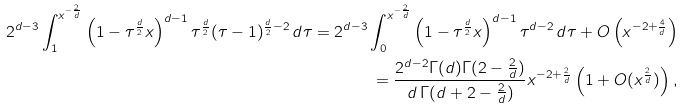Convert formula to latex. <formula><loc_0><loc_0><loc_500><loc_500>2 ^ { d - 3 } \int _ { 1 } ^ { x ^ { - \frac { 2 } { d } } } \left ( 1 - \tau ^ { \frac { d } { 2 } } x \right ) ^ { d - 1 } \tau ^ { \frac { d } { 2 } } ( \tau - 1 ) ^ { \frac { d } { 2 } - 2 } \, d \tau = 2 ^ { d - 3 } \int _ { 0 } ^ { x ^ { - \frac { 2 } { d } } } \left ( 1 - \tau ^ { \frac { d } { 2 } } x \right ) ^ { d - 1 } \tau ^ { d - 2 } \, d \tau + O \left ( x ^ { - 2 + \frac { 4 } { d } } \right ) \\ = \frac { 2 ^ { d - 2 } \Gamma ( d ) \Gamma ( 2 - \frac { 2 } { d } ) } { d \, \Gamma ( d + 2 - \frac { 2 } { d } ) } x ^ { - 2 + \frac { 2 } { d } } \left ( 1 + O ( x ^ { \frac { 2 } { d } } ) \right ) ,</formula> 